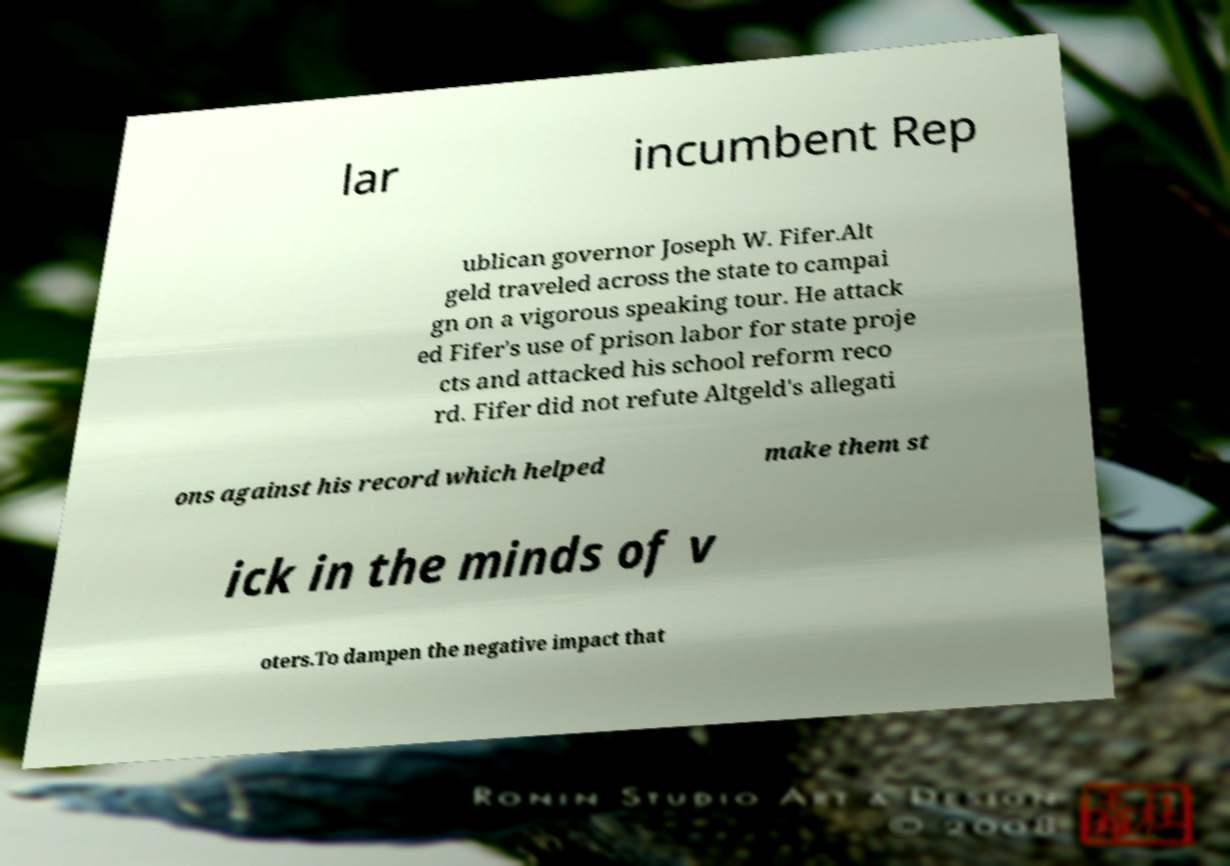I need the written content from this picture converted into text. Can you do that? lar incumbent Rep ublican governor Joseph W. Fifer.Alt geld traveled across the state to campai gn on a vigorous speaking tour. He attack ed Fifer's use of prison labor for state proje cts and attacked his school reform reco rd. Fifer did not refute Altgeld's allegati ons against his record which helped make them st ick in the minds of v oters.To dampen the negative impact that 